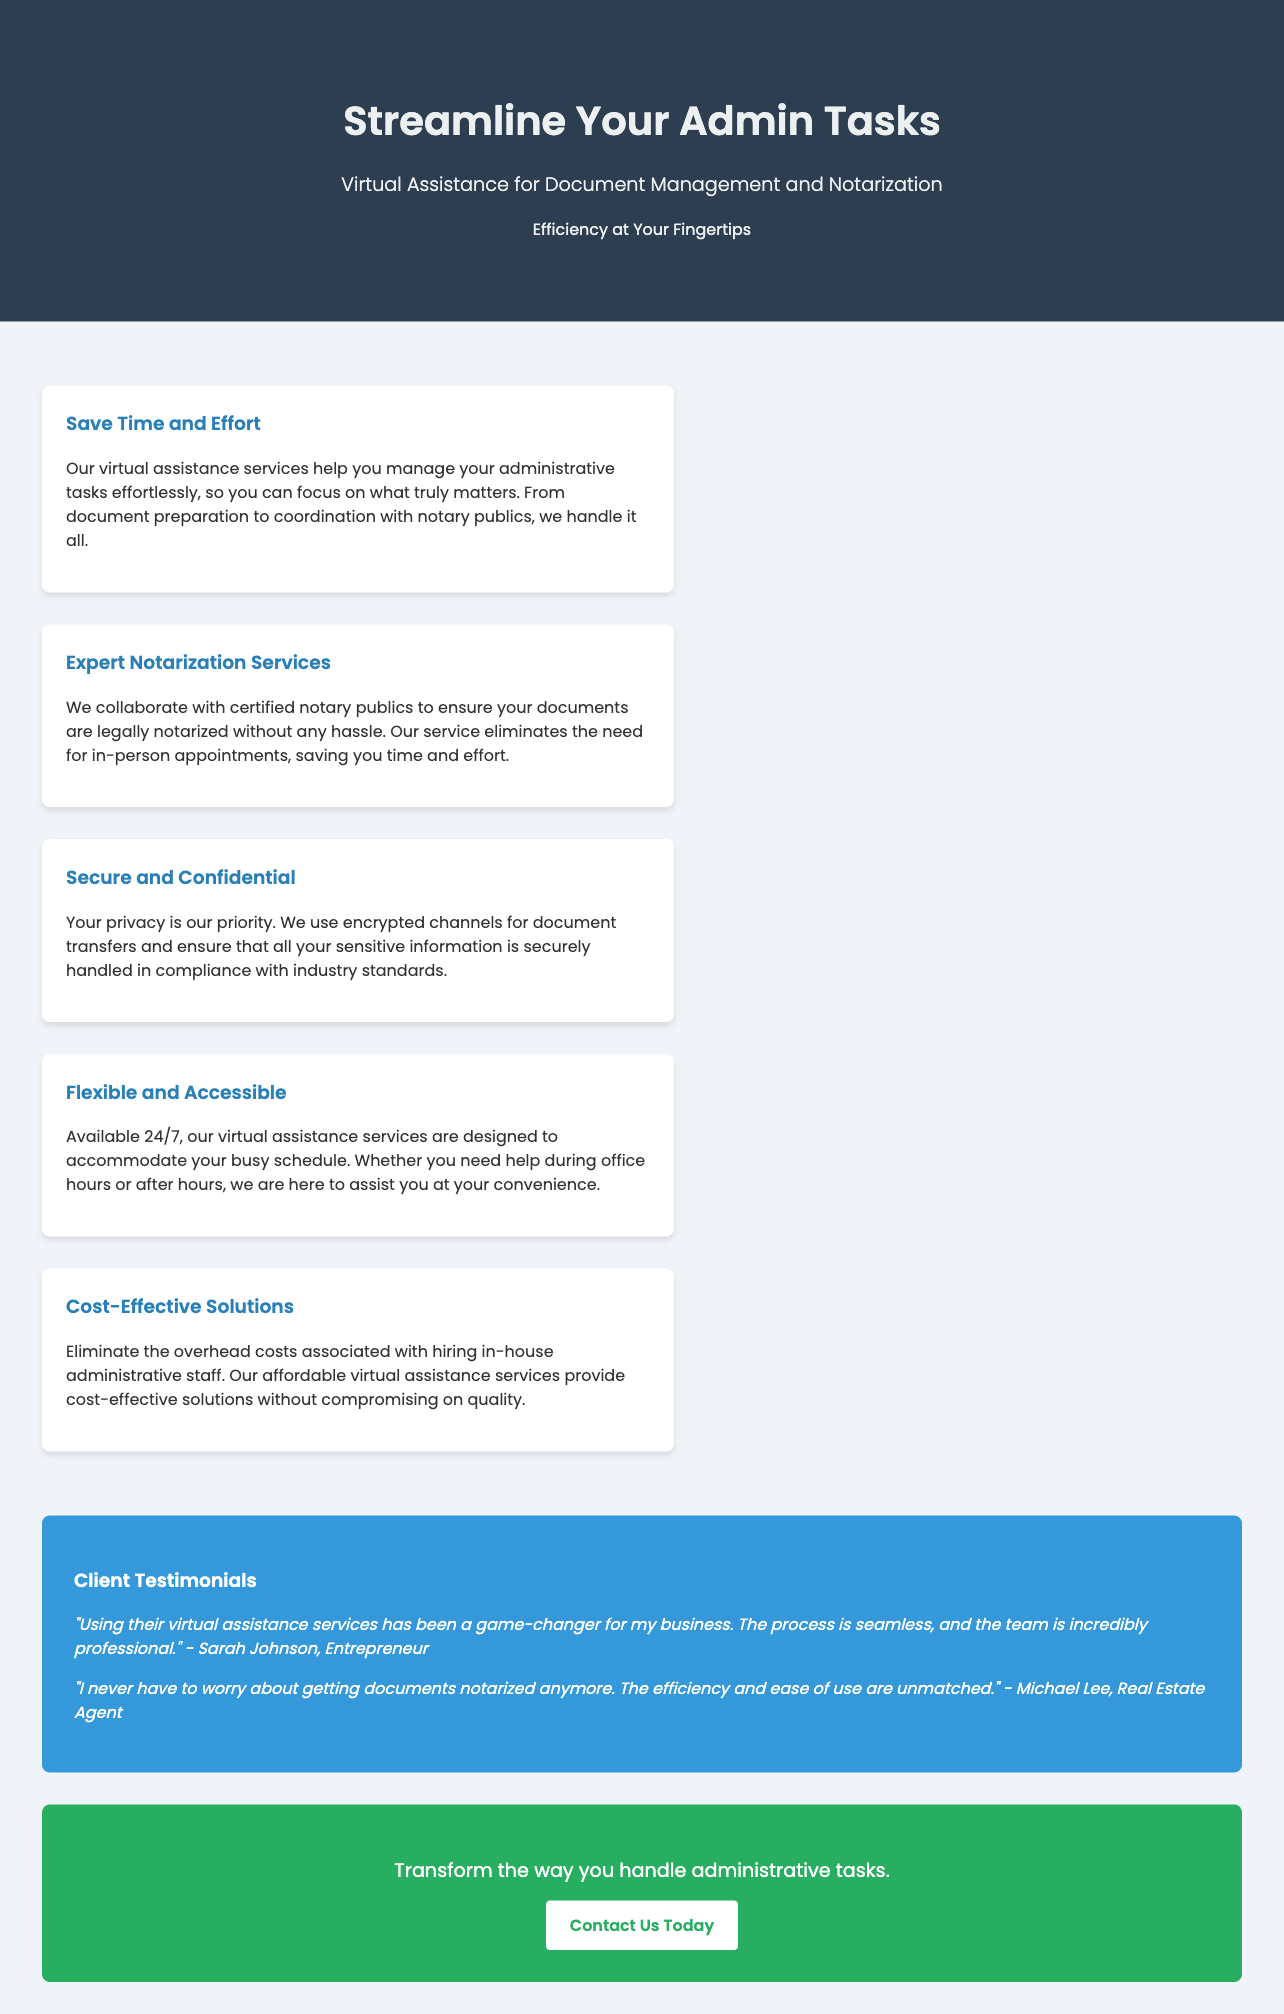What is the title of the advertisement? The title of the advertisement is displayed prominently at the top of the document.
Answer: Streamline Your Admin Tasks What service does the tagline describe? The tagline succinctly encapsulates the main service offered in the advertisement.
Answer: Virtual Assistance for Document Management and Notarization What are the working hours of the service? The advertisement states the service availability to highlight its flexibility regarding client schedules.
Answer: 24/7 What kind of experts does the service collaborate with? This information pertains to the type of professionals involved in the notarization process, mentioned in the advertisement.
Answer: Certified notary publics What is the main benefit of using this virtual assistance? This question addresses the primary advantage emphasized in the document regarding time management.
Answer: Save Time and Effort Who provided a testimonial referring to the service’s seamless process? This question checks the client testimonials segment of the advertisement for user satisfaction.
Answer: Sarah Johnson What is mentioned as a priority in handling documents? This focuses on the care taken with sensitive information, a key point made in the advertisement.
Answer: Your privacy What is the color of the call-to-action button? This question pertains to the specific details of the design elements in the advertisement's CTA section.
Answer: White What phrase describes the overall focus of the advertisement? This seeks to summarize the primary theme and purpose stated within the advertisement.
Answer: Efficiency at Your Fingertips 